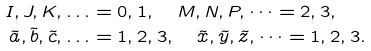Convert formula to latex. <formula><loc_0><loc_0><loc_500><loc_500>I , J , K , \dots & = 0 , 1 , \quad M , N , P , \dots = 2 , 3 , \\ \tilde { a } , \tilde { b } , \tilde { c } , \dots & = 1 , 2 , 3 , \quad \tilde { x } , \tilde { y } , \tilde { z } , \dots = 1 , 2 , 3 .</formula> 